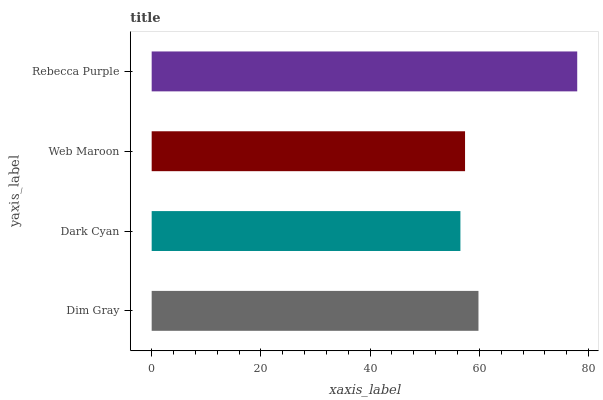Is Dark Cyan the minimum?
Answer yes or no. Yes. Is Rebecca Purple the maximum?
Answer yes or no. Yes. Is Web Maroon the minimum?
Answer yes or no. No. Is Web Maroon the maximum?
Answer yes or no. No. Is Web Maroon greater than Dark Cyan?
Answer yes or no. Yes. Is Dark Cyan less than Web Maroon?
Answer yes or no. Yes. Is Dark Cyan greater than Web Maroon?
Answer yes or no. No. Is Web Maroon less than Dark Cyan?
Answer yes or no. No. Is Dim Gray the high median?
Answer yes or no. Yes. Is Web Maroon the low median?
Answer yes or no. Yes. Is Dark Cyan the high median?
Answer yes or no. No. Is Dim Gray the low median?
Answer yes or no. No. 